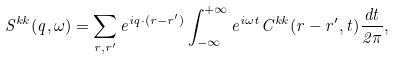Convert formula to latex. <formula><loc_0><loc_0><loc_500><loc_500>S ^ { k k } ( { q } , \omega ) = \sum _ { { r } , { r ^ { \prime } } } e ^ { i { q } \cdot ( { r } - { r ^ { \prime } } ) } \int ^ { + \infty } _ { - \infty } e ^ { i \omega t } C ^ { k k } ( { r } - { r ^ { \prime } } , t ) \frac { d t } { 2 \pi } ,</formula> 